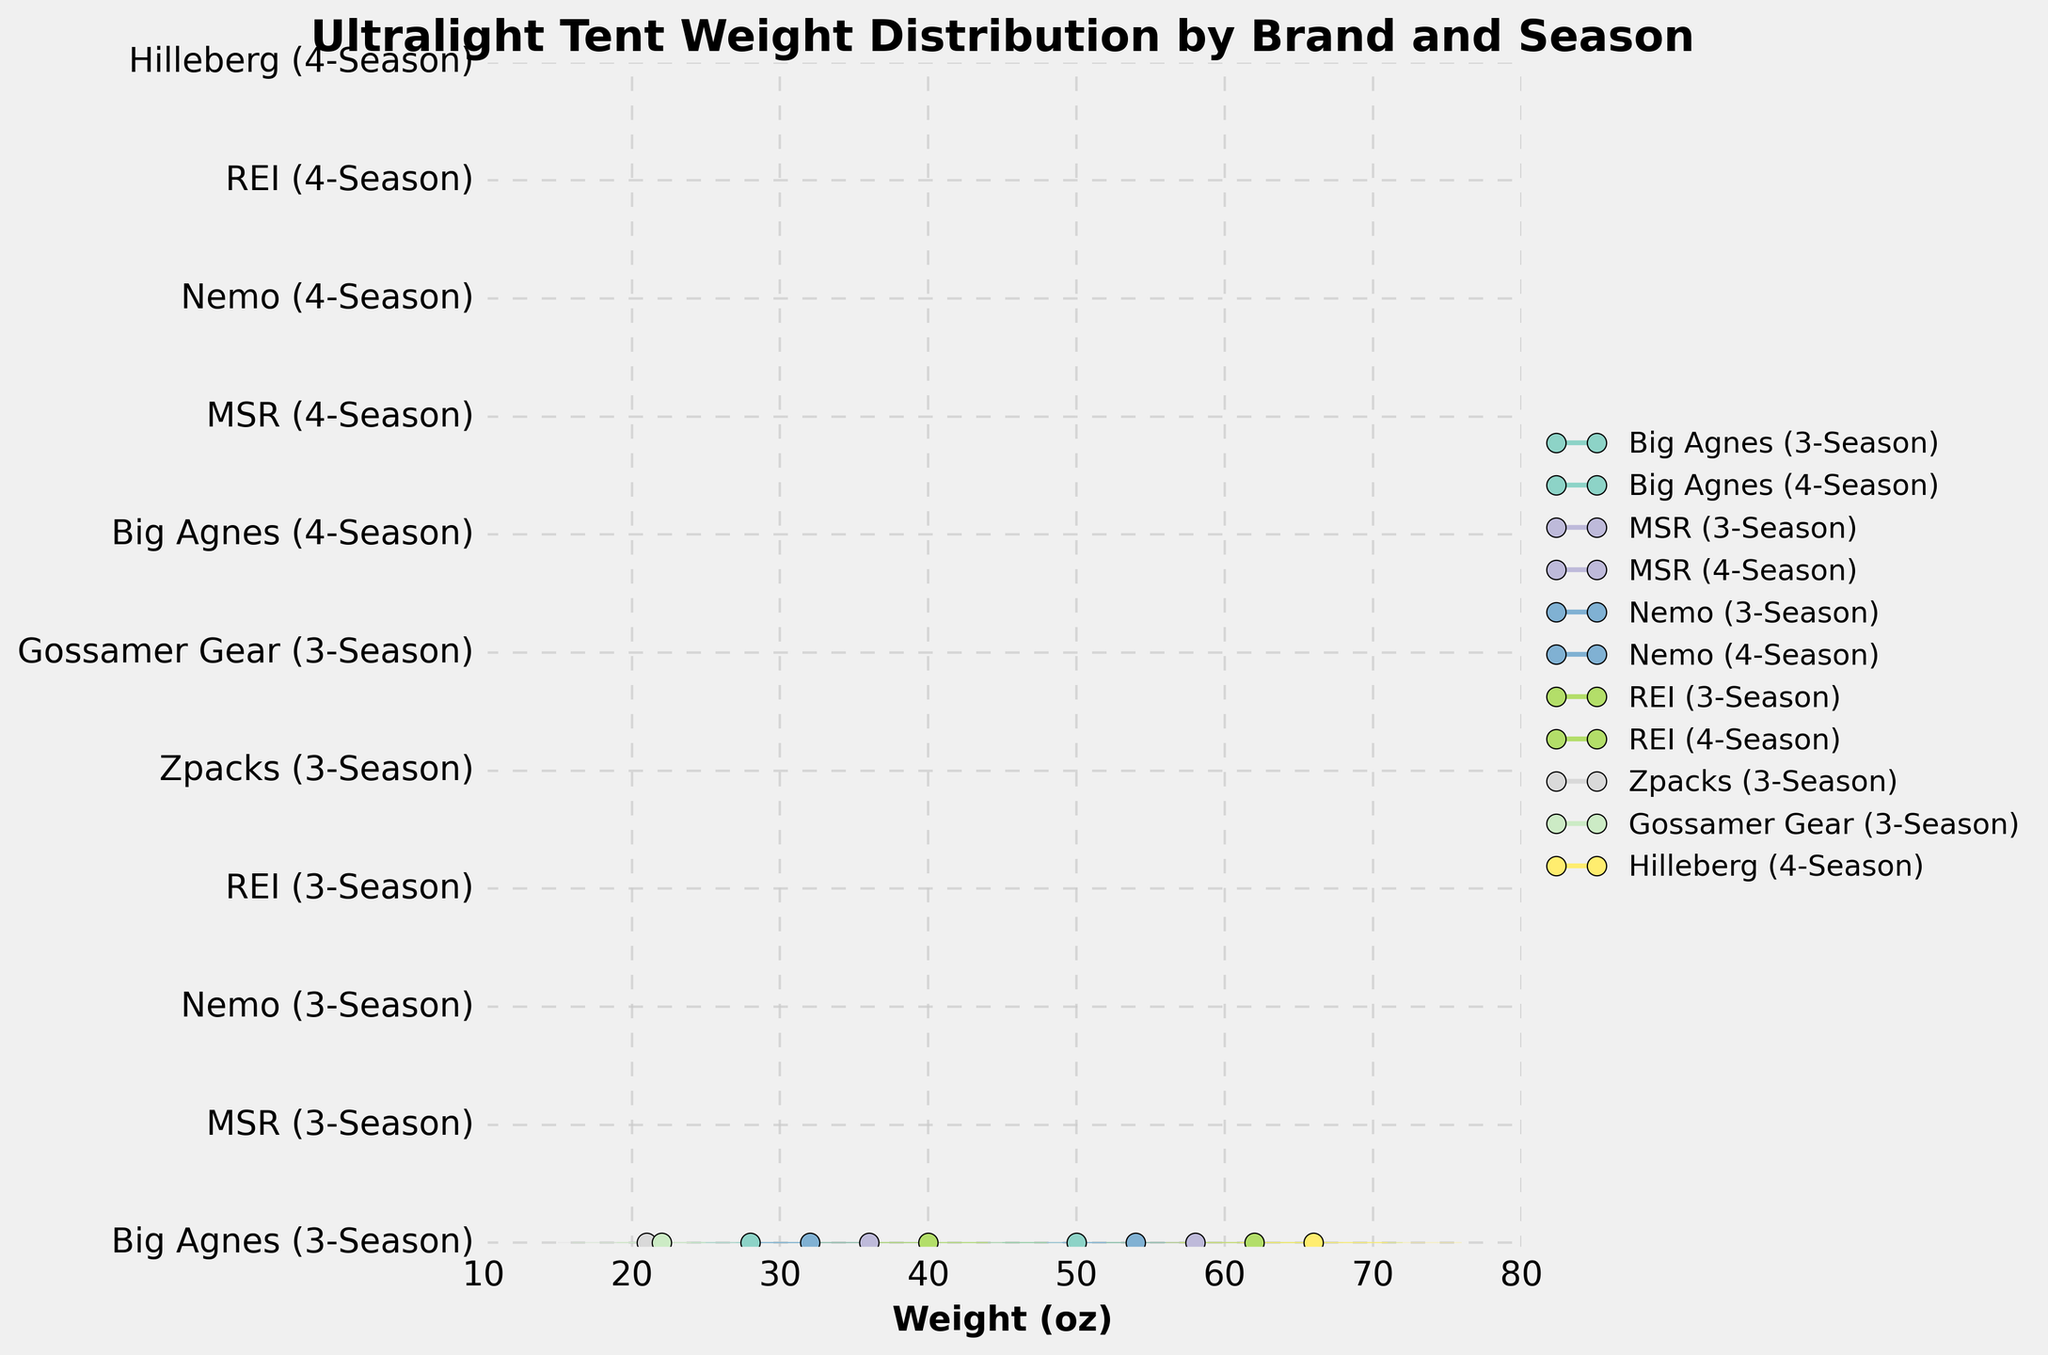What's the title of the figure? The title is located at the top of the figure and reads "Ultralight Tent Weight Distribution by Brand and Season".
Answer: Ultralight Tent Weight Distribution by Brand and Season What are the x-axis and y-axis labels? The x-axis label is situated at the bottom of the figure and reads "Weight (oz)" while the y-axis labels each brand and season combination like "Big Agnes (3-Season)", "MSR (3-Season)", and so on.
Answer: Weight (oz), brand and season combinations Which brand and season combination has the lightest median tent weight? By observing the position of the median markers (small circles) for each brand and season on the x-axis, "Zpacks (3-Season)" has the furthest left median marker, indicating the lightest weight.
Answer: Zpacks (3-Season) Which brand and season combination has the heaviest maximum tent weight? The maximum tent weight for each combination is represented by the right-most boundary of the filled area. "Hilleberg (4-Season)" extends furthest to the right, indicating the heaviest maximum weight.
Answer: Hilleberg (4-Season) How much heavier is the median weight of REI's 4-Season tent compared to its 3-Season tent? The median weight markers for REI's 3-Season and 4-Season tents are compared. The 3-Season median is at 40 oz and the 4-Season median is at 62 oz. The difference is 62 - 40 = 22 oz.
Answer: 22 oz What's the interquartile range (IQR) for MSR's 3-Season tent weights? IQR is calculated as Q3 minus Q1. For MSR's 3-Season tent, Q3 is 40 oz and Q1 is 32 oz. Therefore, the IQR is 40 - 32 = 8 oz.
Answer: 8 oz Compare the median weights of Big Agnes tents across the 3-Season and 4-Season. Which one is heavier? The median weights for Big Agnes tents can be seen from the median markers. The 3-Season median is 28 oz, and the 4-Season median is 50 oz. The 4-Season tent is heavier.
Answer: 4-Season Which three brand and season combinations have the narrowest range between the minimum and maximum weights? Narrow range can be identified by the smallest width of the filled areas. "Zpacks (3-Season)", "Gossamer Gear (3-Season)", and "Big Agnes (3-Season)" have the narrowest ranges.
Answer: Zpacks (3-Season), Gossamer Gear (3-Season), Big Agnes (3-Season) How does the weight distribution of 3-Season tents across all brands compare to the 4-Season tents? Observing the overall spread and median locations of the filled areas, 3-Season tents have a lower and narrower weight range compared to the 4-Season tents, which are overall heavier and have a wider range.
Answer: 3-Season tents are lighter and narrower in range Which brand's 3-Season tents have the closest median weights? Comparing the median markers of the 3-Season tents, "Nemo", "Gossamer Gear", and "Big Agnes" appear to have similar median weights, close to 28 oz.
Answer: Nemo, Gossamer Gear, Big Agnes 